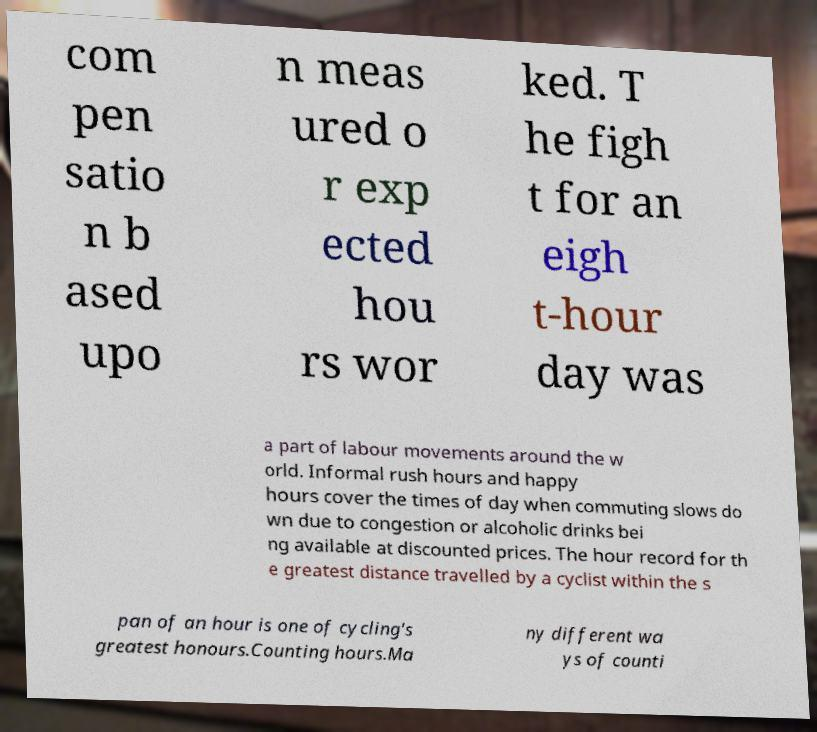Could you assist in decoding the text presented in this image and type it out clearly? com pen satio n b ased upo n meas ured o r exp ected hou rs wor ked. T he figh t for an eigh t-hour day was a part of labour movements around the w orld. Informal rush hours and happy hours cover the times of day when commuting slows do wn due to congestion or alcoholic drinks bei ng available at discounted prices. The hour record for th e greatest distance travelled by a cyclist within the s pan of an hour is one of cycling's greatest honours.Counting hours.Ma ny different wa ys of counti 